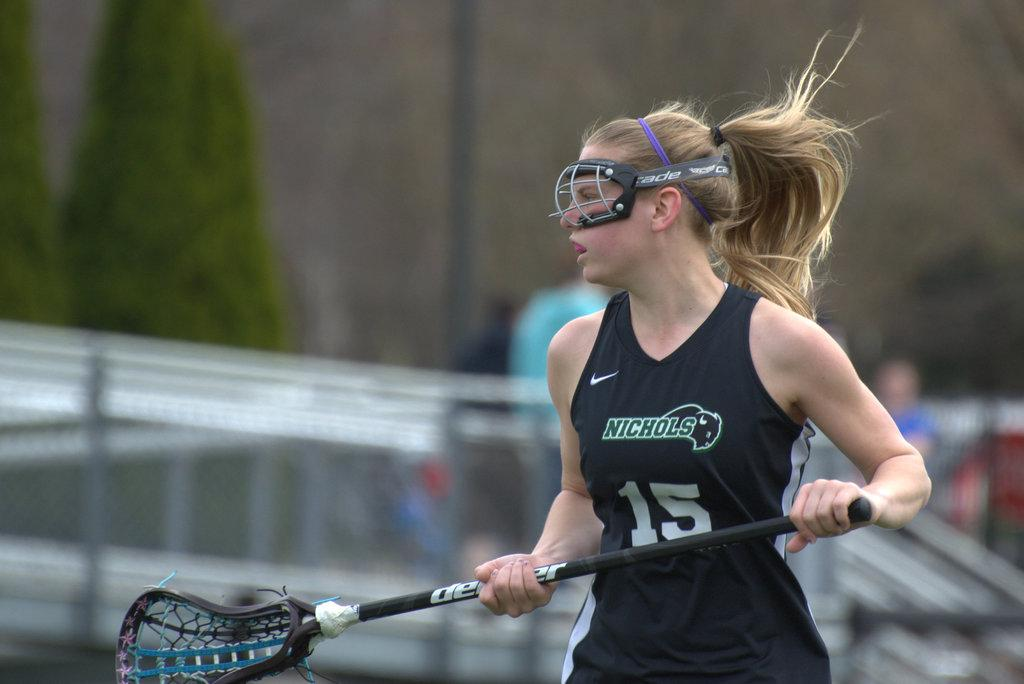Who is the main subject in the image? There is a lady in the center of the image. What is the lady wearing on her face? The lady is wearing a mask. What is the lady holding in her hand? The lady is holding a stick. What can be seen in the background of the image? There are railings, trees, and people in the background of the image. There is also a wall in the background. What type of act is the lady performing with the branch in the image? There is no branch present in the image, and the lady is holding a stick, not a branch. 